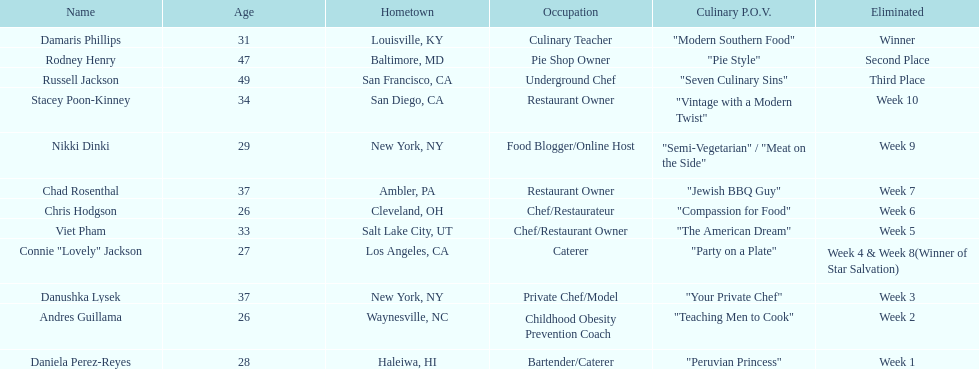Who are the individuals competing? Damaris Phillips, 31, Rodney Henry, 47, Russell Jackson, 49, Stacey Poon-Kinney, 34, Nikki Dinki, 29, Chad Rosenthal, 37, Chris Hodgson, 26, Viet Pham, 33, Connie "Lovely" Jackson, 27, Danushka Lysek, 37, Andres Guillama, 26, Daniela Perez-Reyes, 28. What is the age of chris hodgson? 26. Is there another participant with an identical age? Andres Guillama. 